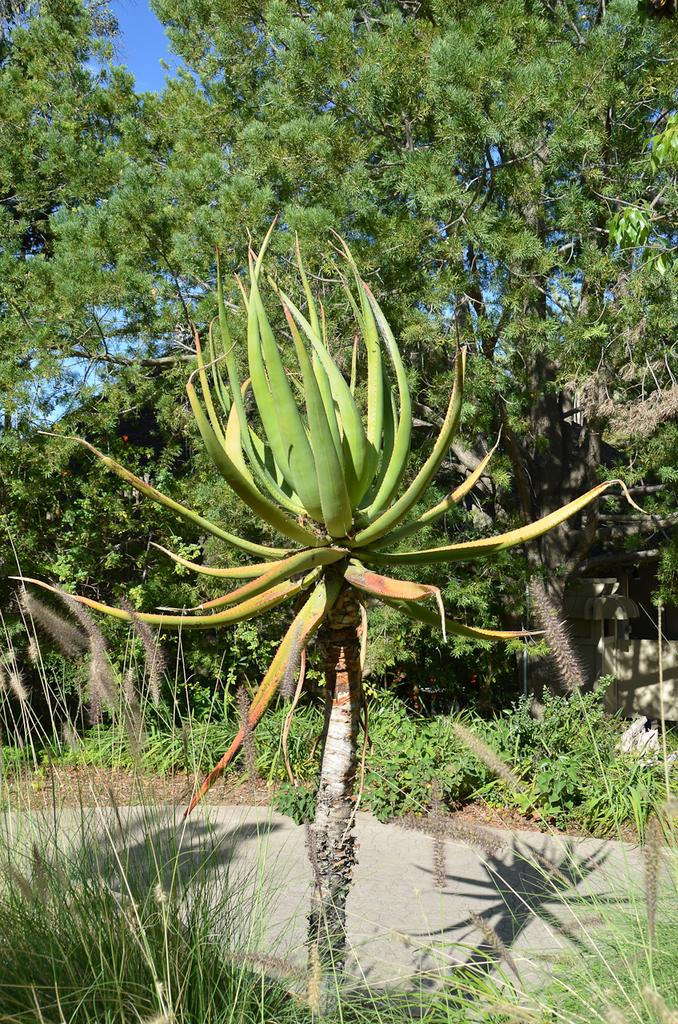What type of living organism can be seen in the image? There is a plant in the image. What can be seen in the background of the image? There is a group of trees and the sky visible in the background of the image. What type of polish is being applied to the zebra in the image? There is no zebra or polish present in the image. 